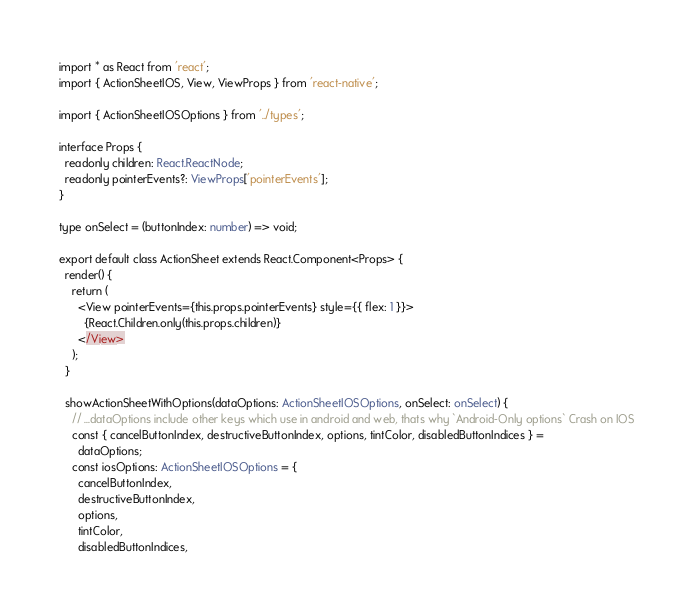<code> <loc_0><loc_0><loc_500><loc_500><_TypeScript_>import * as React from 'react';
import { ActionSheetIOS, View, ViewProps } from 'react-native';

import { ActionSheetIOSOptions } from '../types';

interface Props {
  readonly children: React.ReactNode;
  readonly pointerEvents?: ViewProps['pointerEvents'];
}

type onSelect = (buttonIndex: number) => void;

export default class ActionSheet extends React.Component<Props> {
  render() {
    return (
      <View pointerEvents={this.props.pointerEvents} style={{ flex: 1 }}>
        {React.Children.only(this.props.children)}
      </View>
    );
  }

  showActionSheetWithOptions(dataOptions: ActionSheetIOSOptions, onSelect: onSelect) {
    // ...dataOptions include other keys which use in android and web, thats why `Android-Only options` Crash on IOS
    const { cancelButtonIndex, destructiveButtonIndex, options, tintColor, disabledButtonIndices } =
      dataOptions;
    const iosOptions: ActionSheetIOSOptions = {
      cancelButtonIndex,
      destructiveButtonIndex,
      options,
      tintColor,
      disabledButtonIndices,</code> 